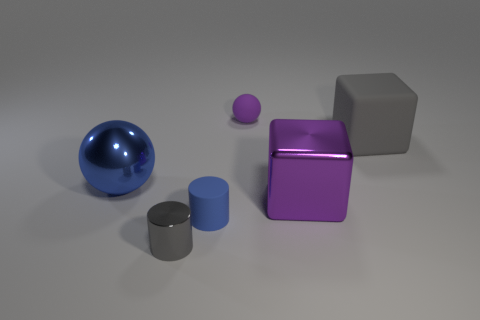There is a object that is the same color as the shiny sphere; what is it made of?
Provide a succinct answer. Rubber. Are there an equal number of rubber cylinders that are on the left side of the shiny sphere and gray blocks that are to the left of the blue matte cylinder?
Offer a very short reply. Yes. There is another object that is the same shape as the purple matte object; what is its size?
Keep it short and to the point. Large. There is a object that is right of the tiny gray shiny cylinder and to the left of the matte sphere; what size is it?
Offer a terse response. Small. How many small purple matte balls are in front of the purple object behind the blue ball?
Your response must be concise. 0. Is the number of matte things in front of the small blue object less than the number of big purple metal blocks to the right of the gray shiny cylinder?
Make the answer very short. Yes. The gray shiny object to the left of the blue object to the right of the big blue metal ball is what shape?
Provide a short and direct response. Cylinder. There is a thing in front of the matte object in front of the gray object that is on the right side of the gray metallic thing; how big is it?
Make the answer very short. Small. Is the size of the metal cylinder the same as the sphere that is on the right side of the tiny rubber cylinder?
Provide a short and direct response. Yes. Is the material of the blue ball the same as the gray cylinder?
Provide a short and direct response. Yes. 